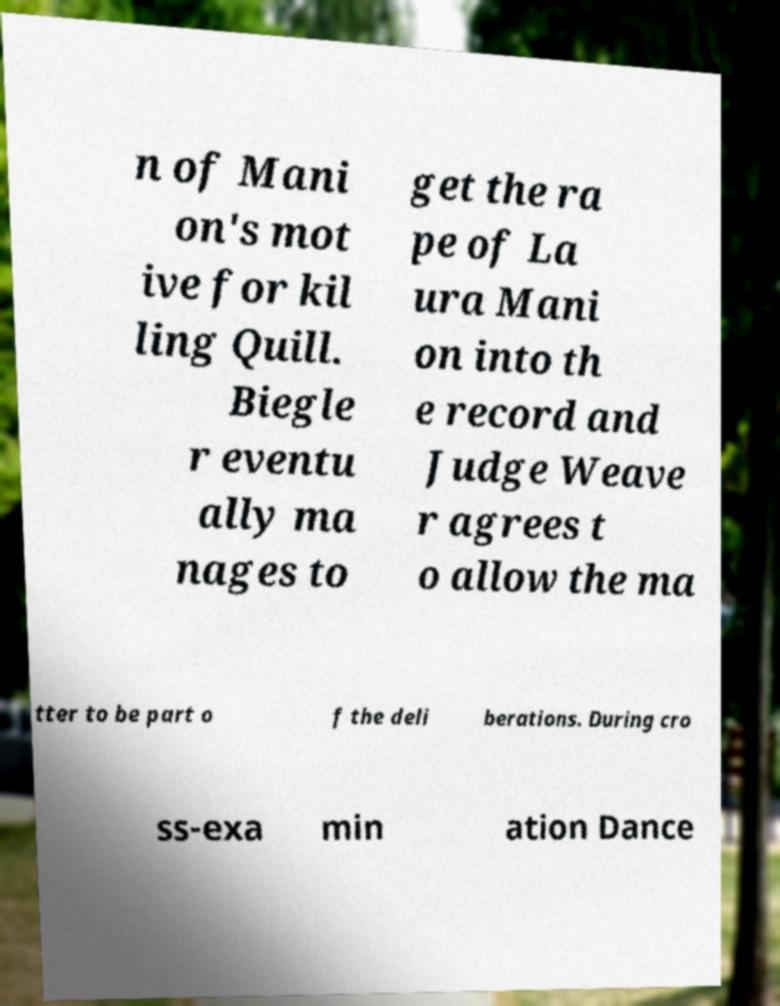Please read and relay the text visible in this image. What does it say? n of Mani on's mot ive for kil ling Quill. Biegle r eventu ally ma nages to get the ra pe of La ura Mani on into th e record and Judge Weave r agrees t o allow the ma tter to be part o f the deli berations. During cro ss-exa min ation Dance 